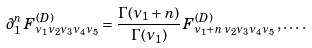Convert formula to latex. <formula><loc_0><loc_0><loc_500><loc_500>\partial _ { 1 } ^ { n } \, F ^ { ( D ) } _ { \nu _ { 1 } \nu _ { 2 } \nu _ { 3 } \nu _ { 4 } \nu _ { 5 } } = \frac { \Gamma ( \nu _ { 1 } + n ) } { \Gamma ( \nu _ { 1 } ) } \, F ^ { ( D ) } _ { \nu _ { 1 } + n \, \nu _ { 2 } \nu _ { 3 } \nu _ { 4 } \nu _ { 5 } } \, , \dots \, .</formula> 